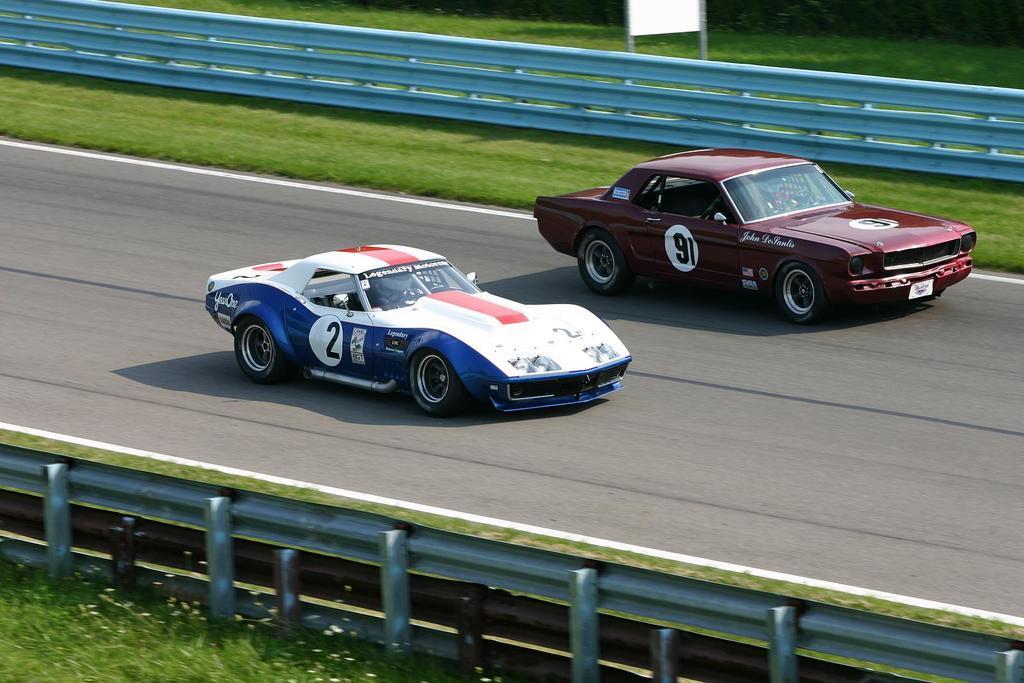Please provide a concise description of this image. In this image I can see two racing cars on the road, in which one is brown in color and the other is blue and white. Also I can see railings on either side of the road and as well as grass on the ground. 